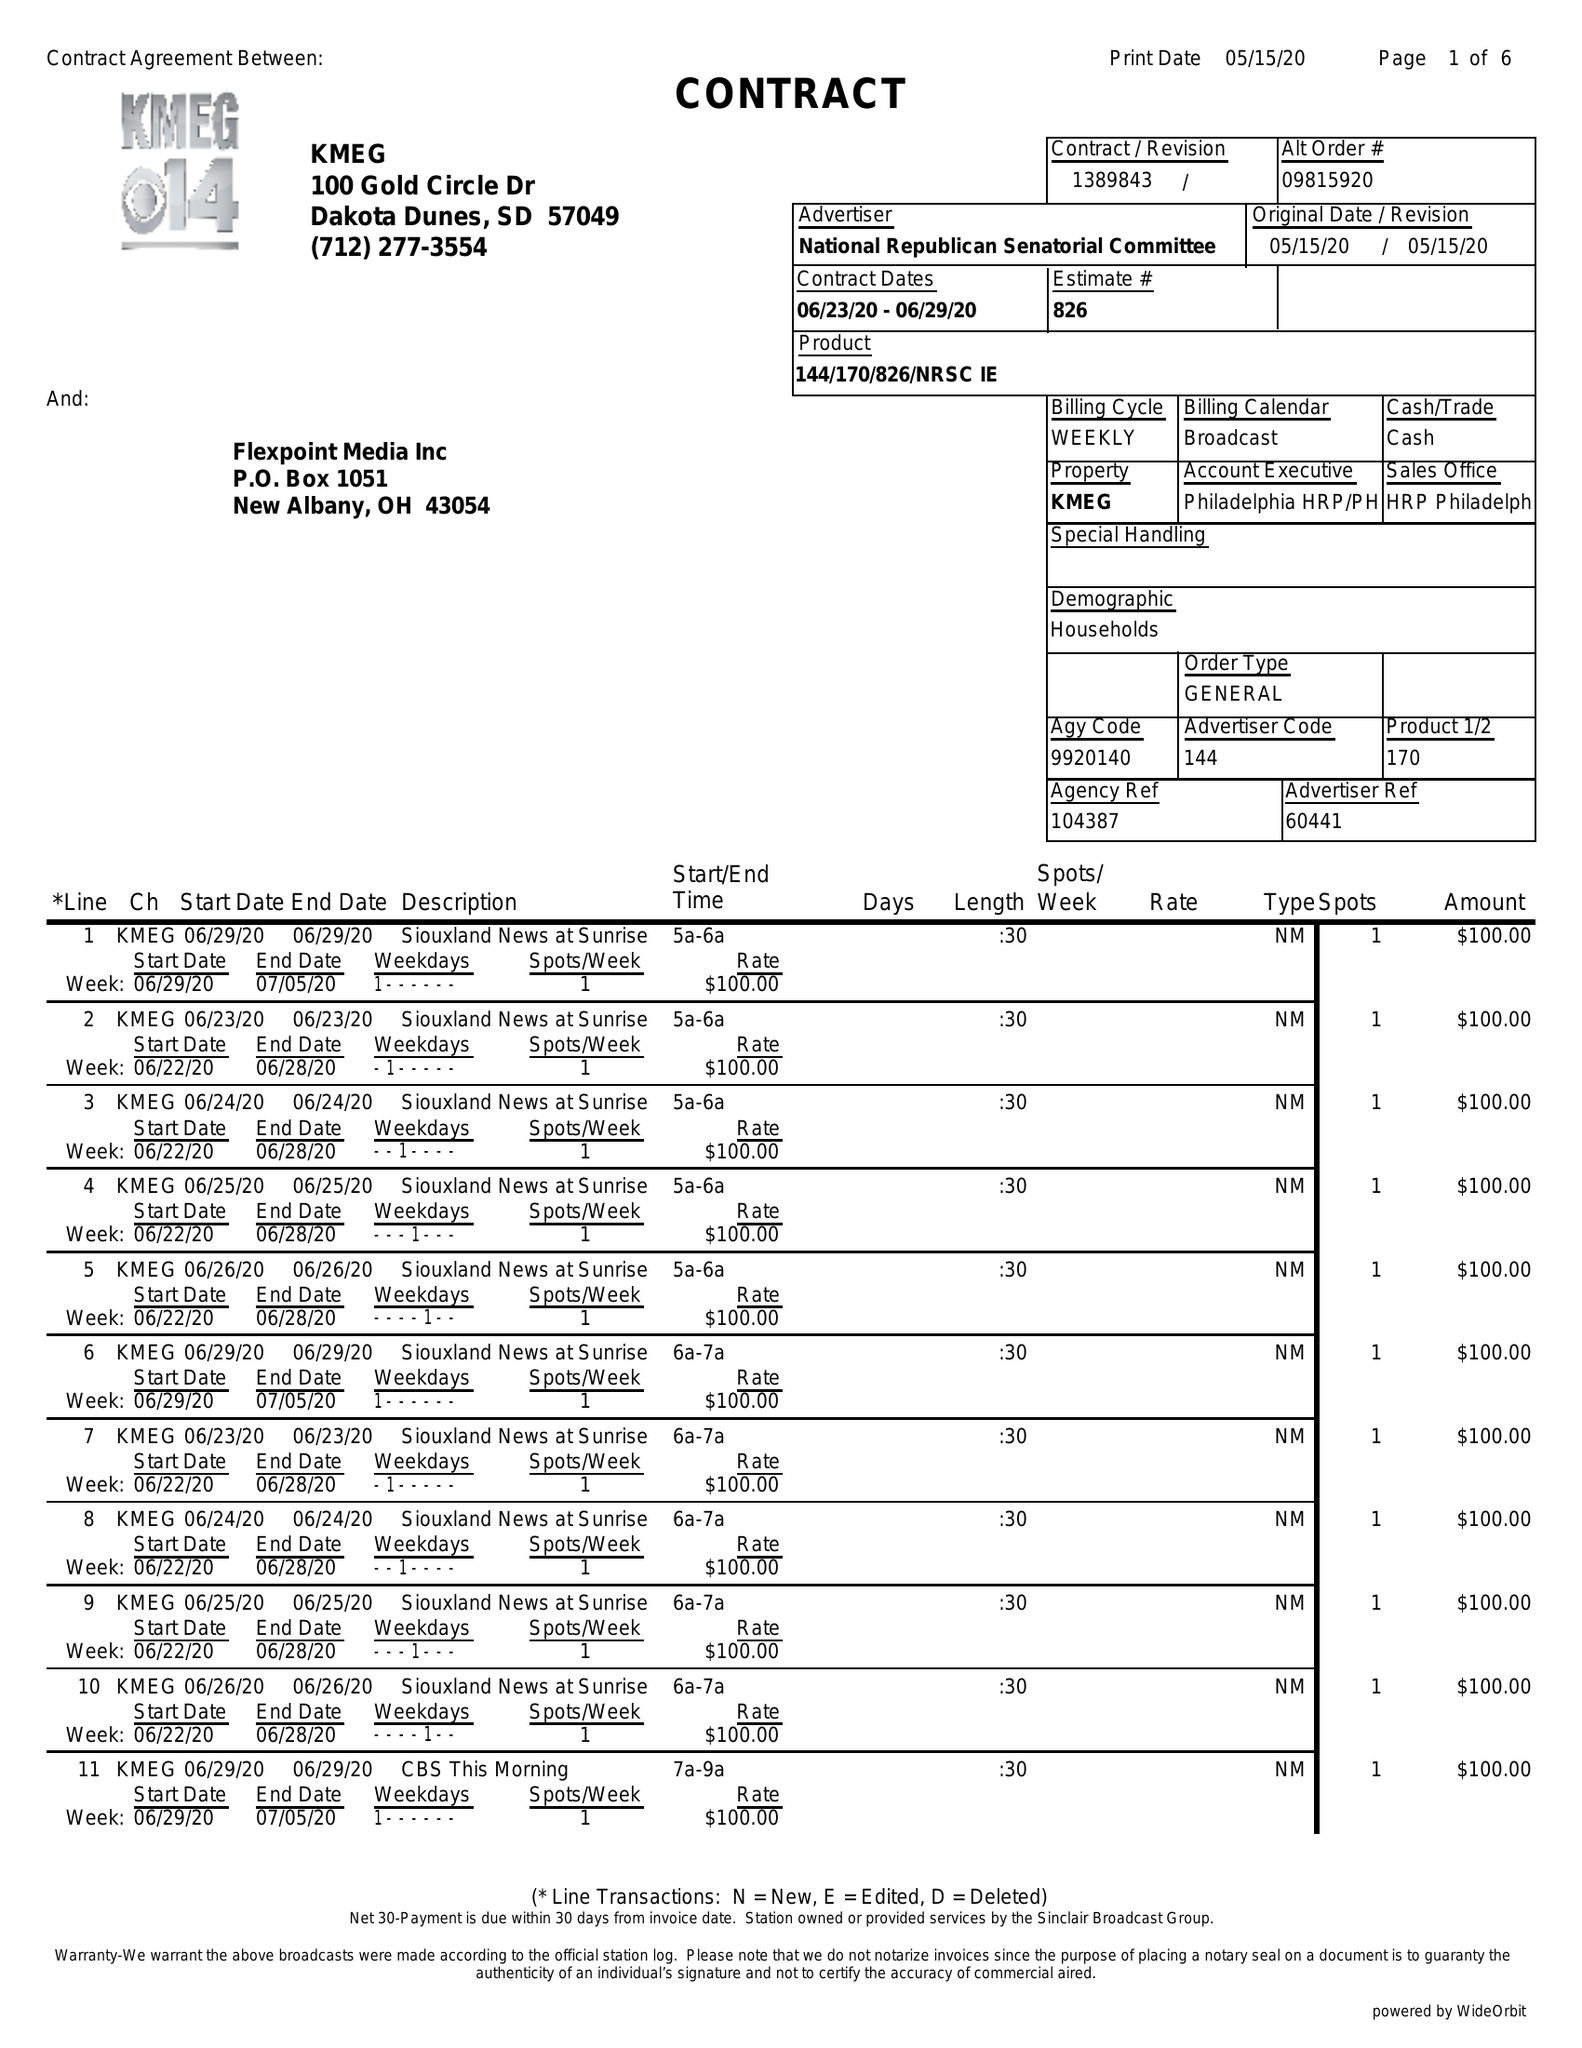What is the value for the advertiser?
Answer the question using a single word or phrase. NATIONAL REPUBLICAN SENATORIAL COMMITTEE 